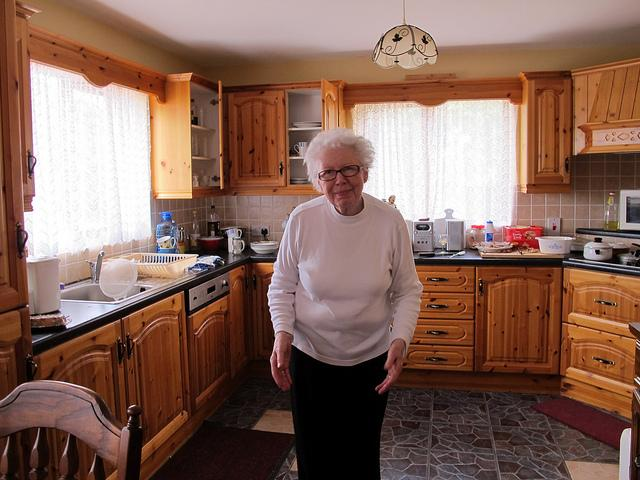Which term would best describe this woman?

Choices:
A) quadragenarian
B) tricenarian
C) quinquagenarian
D) octogenarian octogenarian 